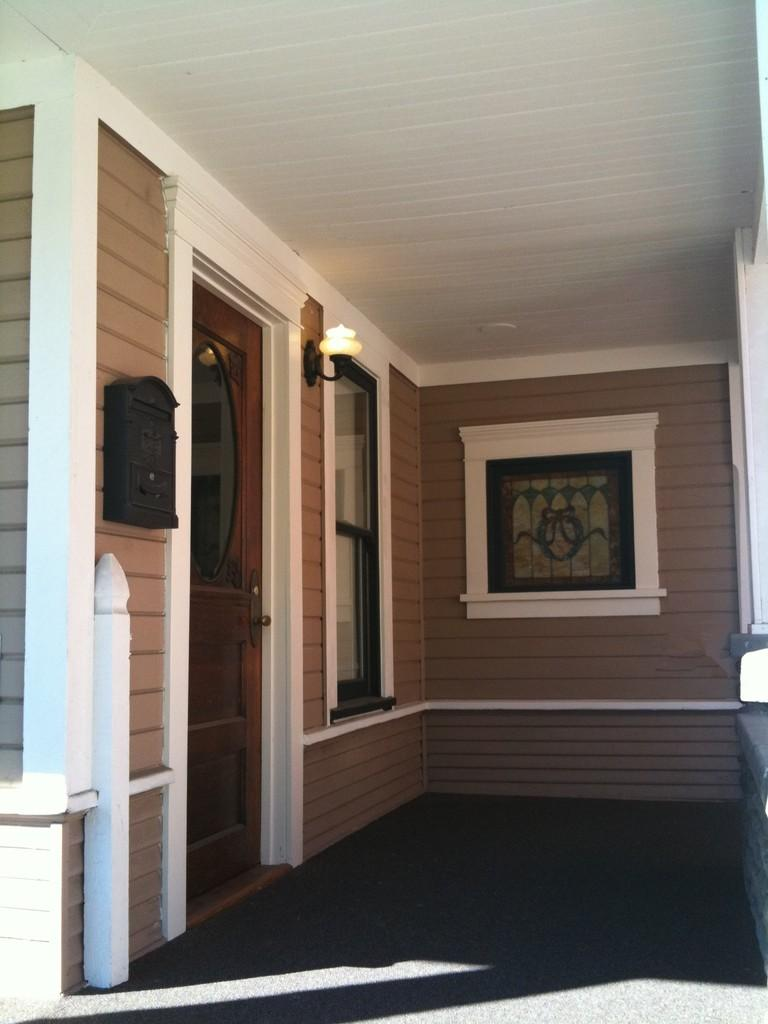What type of opening can be seen in the image? There is a door in the image. What allows natural light to enter the space in the image? There is a window in the image. What is the main object visible in the image? There is an object in the image. What is illuminated on the wall in the image? There is light on the wall in the image. What is above the space in the image? There is a ceiling in the image. What is below the space in the image? There is a floor in the image. Can you see any geese flying through the fog in the image? There is no fog or geese present in the image. 